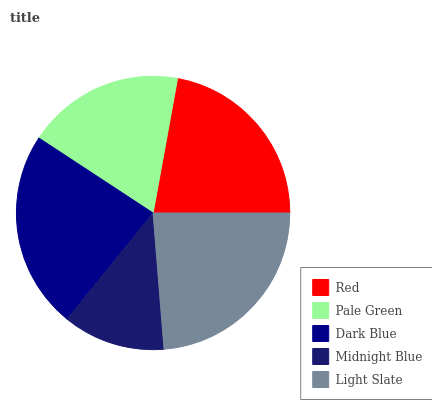Is Midnight Blue the minimum?
Answer yes or no. Yes. Is Light Slate the maximum?
Answer yes or no. Yes. Is Pale Green the minimum?
Answer yes or no. No. Is Pale Green the maximum?
Answer yes or no. No. Is Red greater than Pale Green?
Answer yes or no. Yes. Is Pale Green less than Red?
Answer yes or no. Yes. Is Pale Green greater than Red?
Answer yes or no. No. Is Red less than Pale Green?
Answer yes or no. No. Is Red the high median?
Answer yes or no. Yes. Is Red the low median?
Answer yes or no. Yes. Is Light Slate the high median?
Answer yes or no. No. Is Dark Blue the low median?
Answer yes or no. No. 